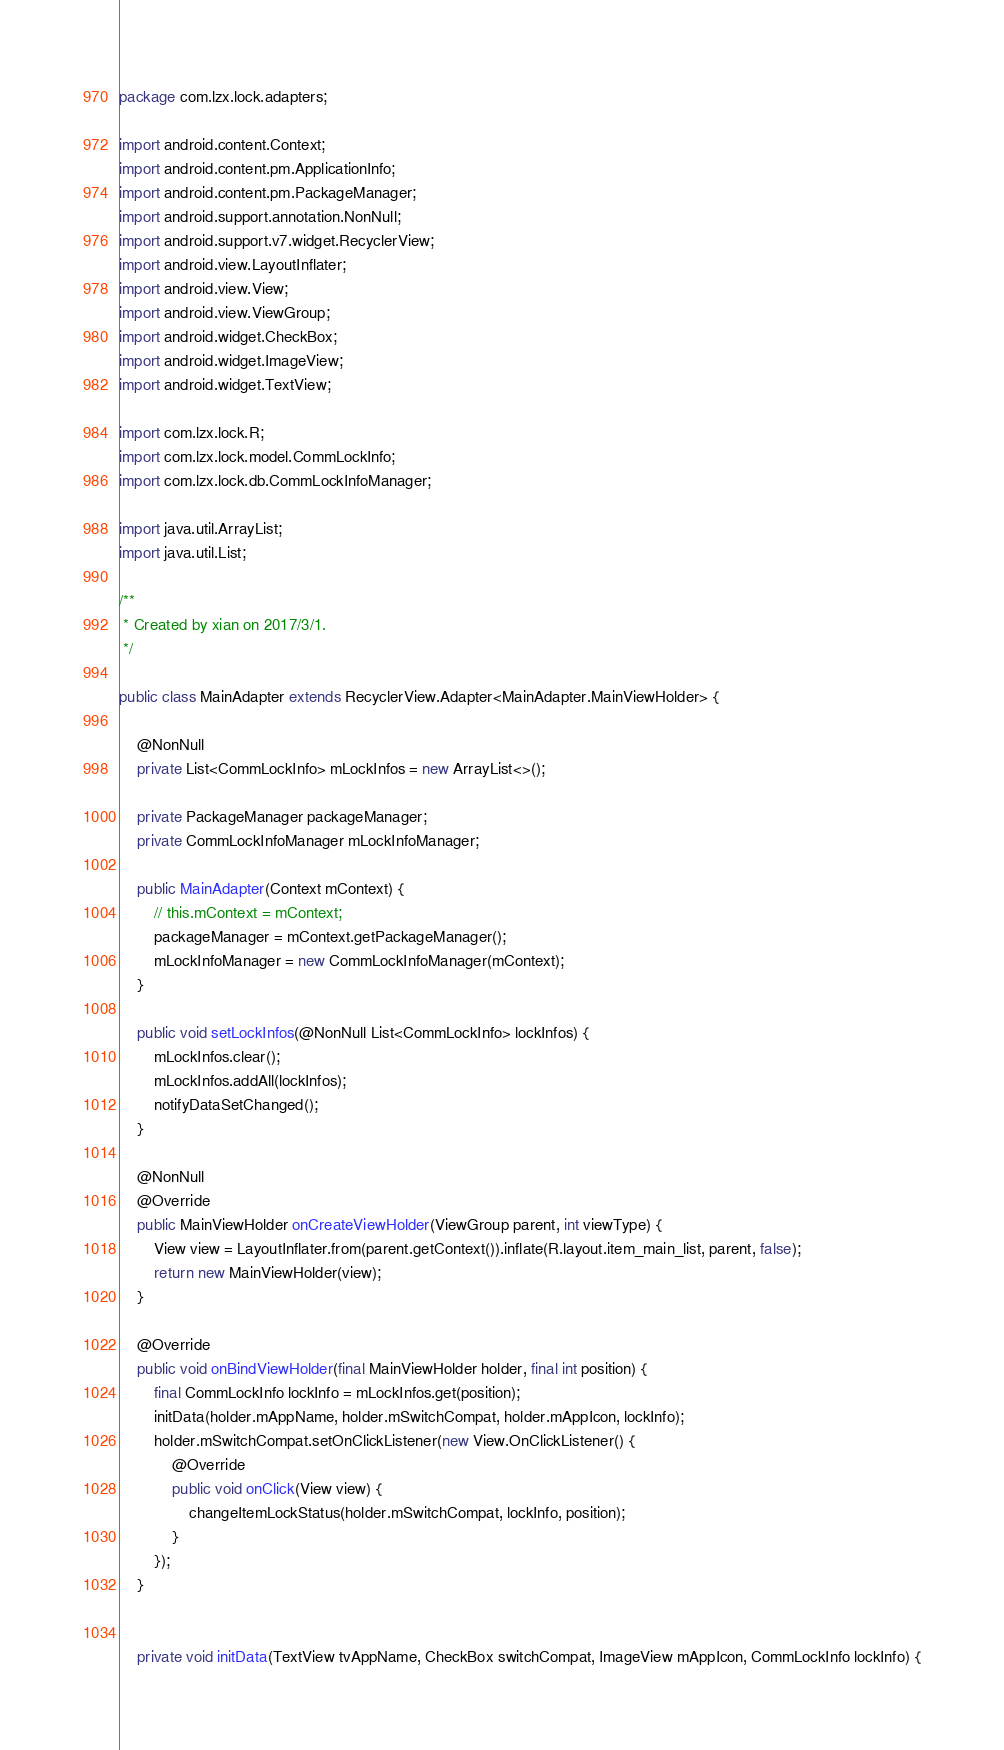Convert code to text. <code><loc_0><loc_0><loc_500><loc_500><_Java_>package com.lzx.lock.adapters;

import android.content.Context;
import android.content.pm.ApplicationInfo;
import android.content.pm.PackageManager;
import android.support.annotation.NonNull;
import android.support.v7.widget.RecyclerView;
import android.view.LayoutInflater;
import android.view.View;
import android.view.ViewGroup;
import android.widget.CheckBox;
import android.widget.ImageView;
import android.widget.TextView;

import com.lzx.lock.R;
import com.lzx.lock.model.CommLockInfo;
import com.lzx.lock.db.CommLockInfoManager;

import java.util.ArrayList;
import java.util.List;

/**
 * Created by xian on 2017/3/1.
 */

public class MainAdapter extends RecyclerView.Adapter<MainAdapter.MainViewHolder> {

    @NonNull
    private List<CommLockInfo> mLockInfos = new ArrayList<>();

    private PackageManager packageManager;
    private CommLockInfoManager mLockInfoManager;

    public MainAdapter(Context mContext) {
        // this.mContext = mContext;
        packageManager = mContext.getPackageManager();
        mLockInfoManager = new CommLockInfoManager(mContext);
    }

    public void setLockInfos(@NonNull List<CommLockInfo> lockInfos) {
        mLockInfos.clear();
        mLockInfos.addAll(lockInfos);
        notifyDataSetChanged();
    }

    @NonNull
    @Override
    public MainViewHolder onCreateViewHolder(ViewGroup parent, int viewType) {
        View view = LayoutInflater.from(parent.getContext()).inflate(R.layout.item_main_list, parent, false);
        return new MainViewHolder(view);
    }

    @Override
    public void onBindViewHolder(final MainViewHolder holder, final int position) {
        final CommLockInfo lockInfo = mLockInfos.get(position);
        initData(holder.mAppName, holder.mSwitchCompat, holder.mAppIcon, lockInfo);
        holder.mSwitchCompat.setOnClickListener(new View.OnClickListener() {
            @Override
            public void onClick(View view) {
                changeItemLockStatus(holder.mSwitchCompat, lockInfo, position);
            }
        });
    }


    private void initData(TextView tvAppName, CheckBox switchCompat, ImageView mAppIcon, CommLockInfo lockInfo) {</code> 